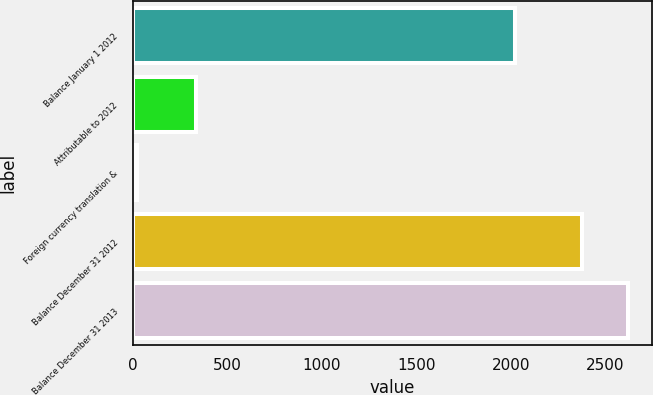Convert chart to OTSL. <chart><loc_0><loc_0><loc_500><loc_500><bar_chart><fcel>Balance January 1 2012<fcel>Attributable to 2012<fcel>Foreign currency translation &<fcel>Balance December 31 2012<fcel>Balance December 31 2013<nl><fcel>2023<fcel>334.4<fcel>20.7<fcel>2378.1<fcel>2617.88<nl></chart> 